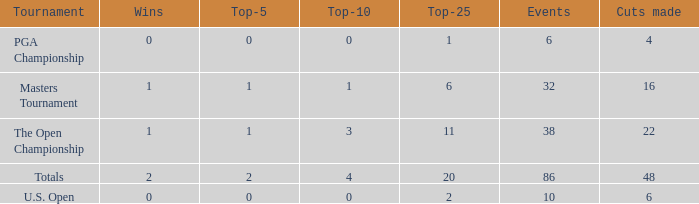Would you mind parsing the complete table? {'header': ['Tournament', 'Wins', 'Top-5', 'Top-10', 'Top-25', 'Events', 'Cuts made'], 'rows': [['PGA Championship', '0', '0', '0', '1', '6', '4'], ['Masters Tournament', '1', '1', '1', '6', '32', '16'], ['The Open Championship', '1', '1', '3', '11', '38', '22'], ['Totals', '2', '2', '4', '20', '86', '48'], ['U.S. Open', '0', '0', '0', '2', '10', '6']]} Tell me the total number of top 25 for wins less than 1 and cuts made of 22 0.0. 